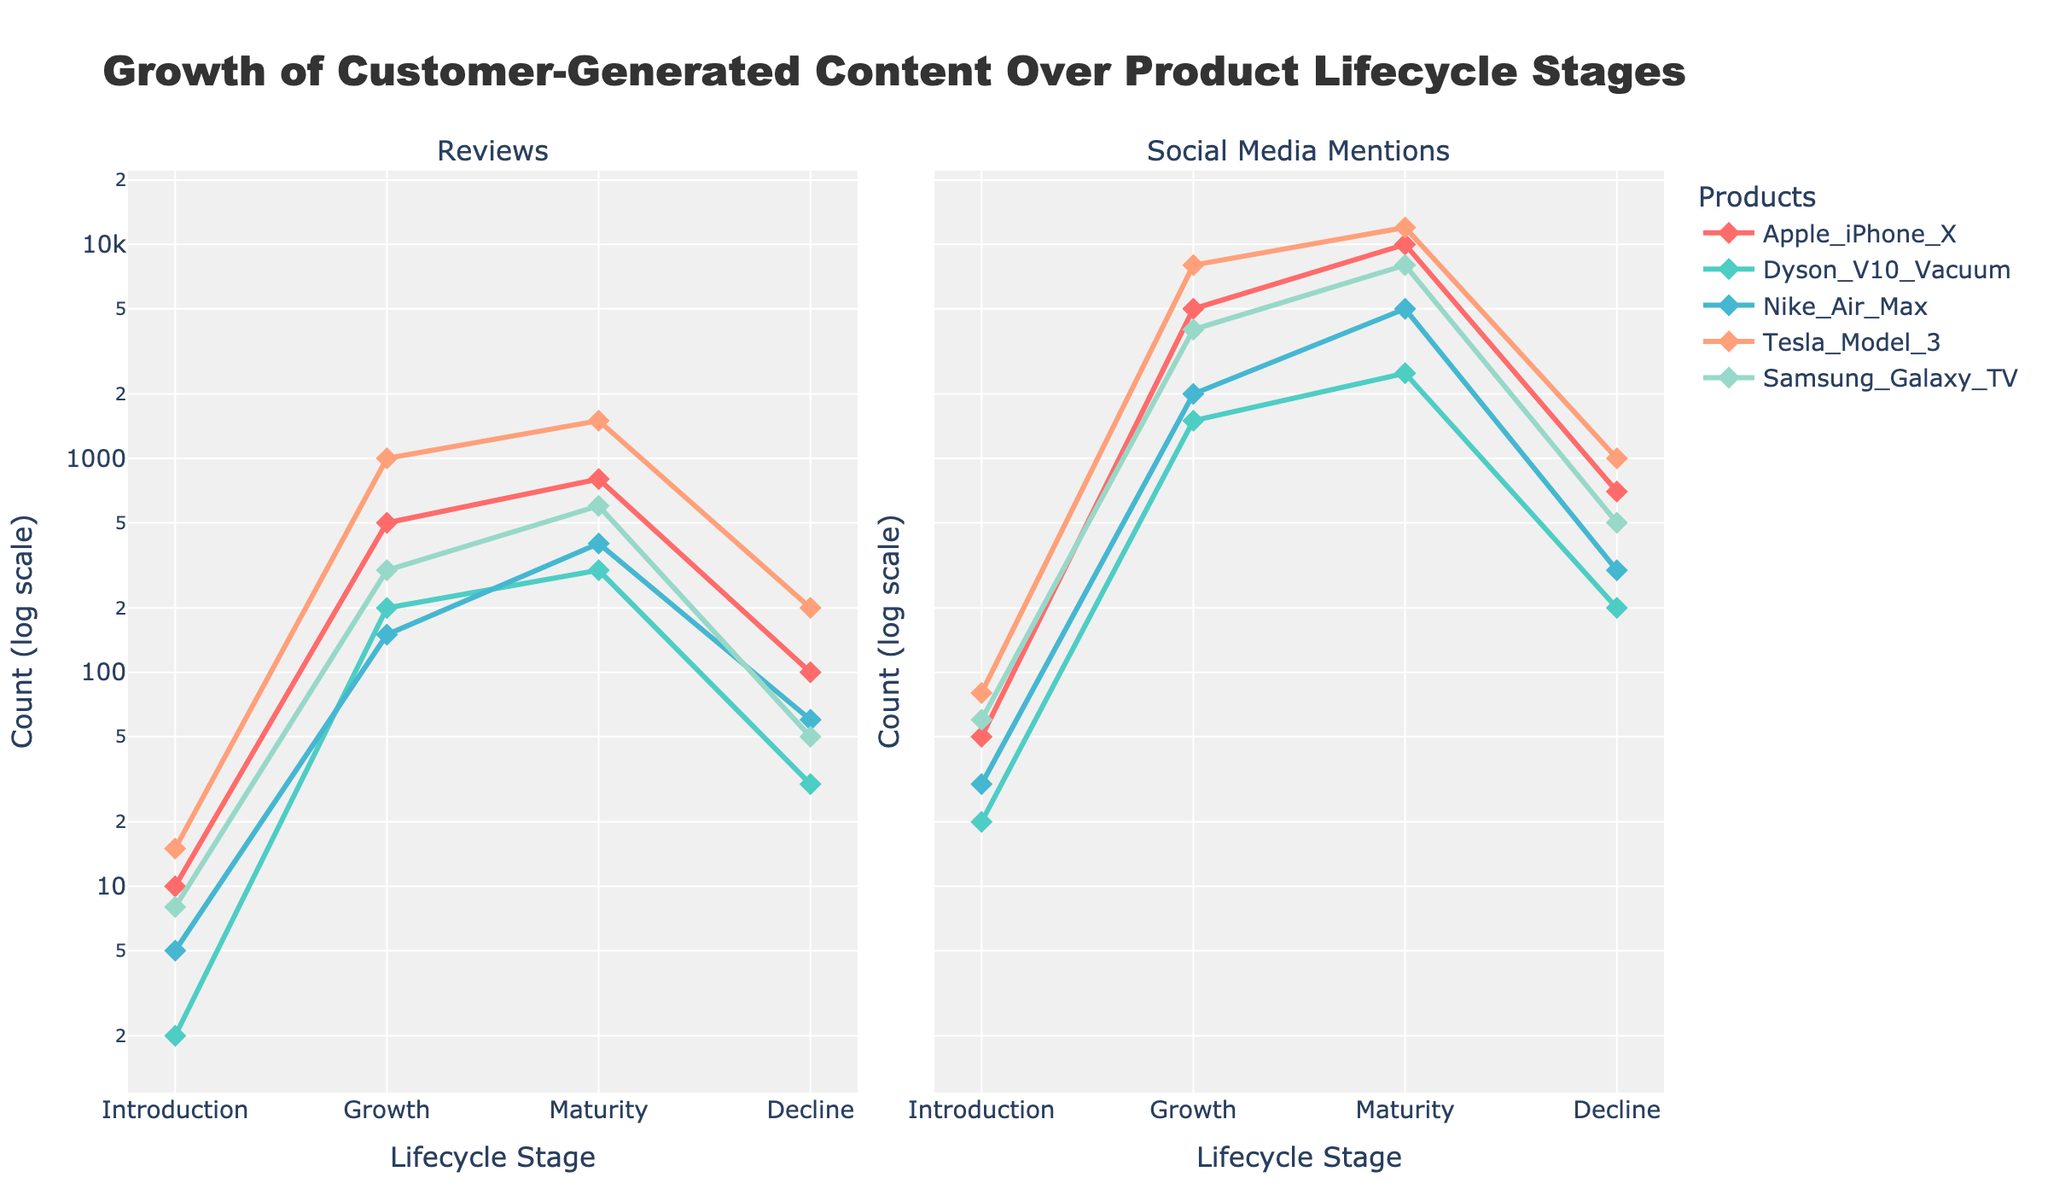What is the overall title of the plot? The overall title is displayed at the top center of the plot and sets the context for the data being visualized, which is "Growth of Customer-Generated Content Over Product Lifecycle Stages".
Answer: Growth of Customer-Generated Content Over Product Lifecycle Stages Which product has the most reviews during the growth stage? By examining the "Reviews" subplot, locate the data points corresponding to the growth stage for each product. Compare the values visually and determine that Tesla Model 3 has the most reviews during this stage.
Answer: Tesla Model 3 How do reviews for the Apple iPhone X change from the introduction to the maturity stage? To determine this, look at the "Reviews" subplot for the Apple iPhone X line. Note the values at the introduction stage (10) and the maturity stage (800) and observe that the reviews increase significantly over these stages.
Answer: Increase significantly Compare the number of social media mentions for the Dyson V10 Vacuum and Nike Air Max in the growth stage. Which has more mentions? In the "Social Media Mentions" subplot, identify the growth stage points for Dyson V10 Vacuum (1500 mentions) and Nike Air Max (2000 mentions) and compare them. Nike Air Max has more mentions.
Answer: Nike Air Max In which product's decline stage do social media mentions decrease to the lowest value among all products? Inspect the "Social Media Mentions" subplot, focusing on the decline stage values for each product. Dyson V10 Vacuum has the lowest value (200 mentions).
Answer: Dyson V10 Vacuum What is the color used to represent the Apple iPhone X? By referencing the legend on the plot, the color representing the Apple iPhone X is identified as light red. This visual cue helps distinguish this product's data from others.
Answer: Light red What is the total number of reviews for Samsung Galaxy TV across all lifecycle stages? Sum the review values for Samsung Galaxy TV from the "Reviews" subplot: 8 (Introduction) + 300 (Growth) + 600 (Maturity) + 50 (Decline) = 958 reviews.
Answer: 958 Which product experiences the most significant drop in reviews from the maturity to the decline stage? Compare the decline in reviews between the maturity and decline stages for each product. Tesla Model 3 shows the largest drop, from 1500 to 200, which is 1300 reviews.
Answer: Tesla Model 3 Among all the products, which has the highest social media mentions in the maturity stage? Look at the "Social Media Mentions" subplot and find the values at the maturity stage for each product. Tesla Model 3 has the highest value with 12000 mentions.
Answer: Tesla Model 3 How does the number of social media mentions for the Apple iPhone X change from the introduction to the decline stage? Examine the "Social Media Mentions" subplot for Apple iPhone X. Note the values at introduction (50), growth (5000), maturity (10000), and decline (700). The mentions increase to a peak at maturity and then decrease significantly at the decline stage.
Answer: Increase, then decrease 